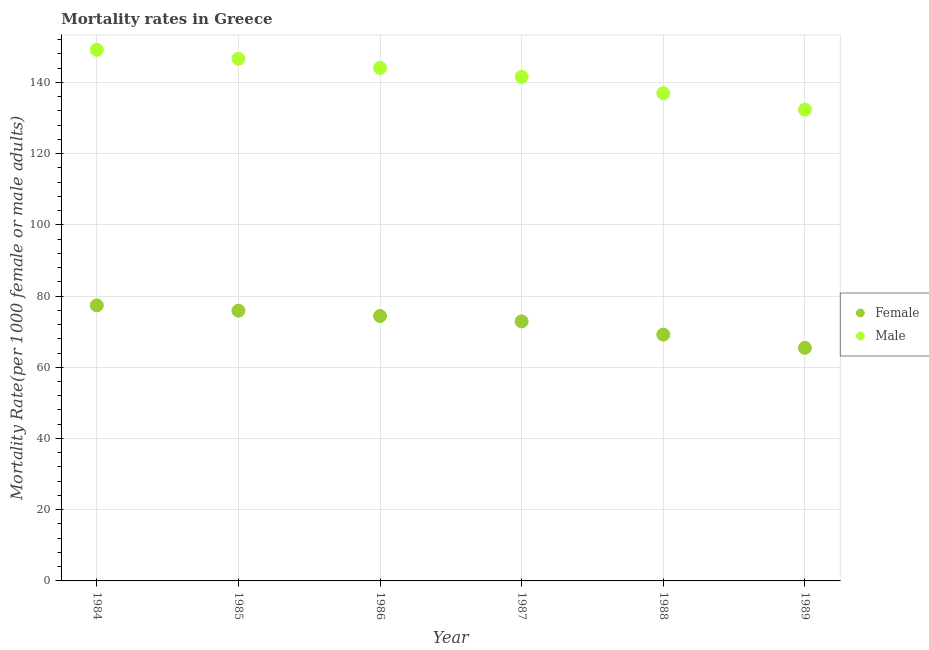Is the number of dotlines equal to the number of legend labels?
Offer a very short reply. Yes. What is the female mortality rate in 1989?
Provide a short and direct response. 65.45. Across all years, what is the maximum male mortality rate?
Ensure brevity in your answer.  149.15. Across all years, what is the minimum male mortality rate?
Make the answer very short. 132.35. In which year was the female mortality rate maximum?
Ensure brevity in your answer.  1984. What is the total male mortality rate in the graph?
Your answer should be very brief. 850.68. What is the difference between the male mortality rate in 1986 and that in 1989?
Offer a very short reply. 11.73. What is the difference between the male mortality rate in 1987 and the female mortality rate in 1984?
Make the answer very short. 64.17. What is the average male mortality rate per year?
Offer a terse response. 141.78. In the year 1988, what is the difference between the male mortality rate and female mortality rate?
Offer a terse response. 67.78. What is the ratio of the male mortality rate in 1986 to that in 1988?
Keep it short and to the point. 1.05. Is the male mortality rate in 1985 less than that in 1988?
Ensure brevity in your answer.  No. What is the difference between the highest and the second highest male mortality rate?
Your answer should be very brief. 2.53. What is the difference between the highest and the lowest female mortality rate?
Offer a very short reply. 11.93. In how many years, is the female mortality rate greater than the average female mortality rate taken over all years?
Offer a terse response. 4. Is the sum of the male mortality rate in 1986 and 1987 greater than the maximum female mortality rate across all years?
Keep it short and to the point. Yes. Is the female mortality rate strictly less than the male mortality rate over the years?
Provide a succinct answer. Yes. How many years are there in the graph?
Give a very brief answer. 6. Where does the legend appear in the graph?
Give a very brief answer. Center right. How are the legend labels stacked?
Give a very brief answer. Vertical. What is the title of the graph?
Keep it short and to the point. Mortality rates in Greece. What is the label or title of the X-axis?
Your response must be concise. Year. What is the label or title of the Y-axis?
Make the answer very short. Mortality Rate(per 1000 female or male adults). What is the Mortality Rate(per 1000 female or male adults) in Female in 1984?
Your answer should be very brief. 77.38. What is the Mortality Rate(per 1000 female or male adults) in Male in 1984?
Make the answer very short. 149.15. What is the Mortality Rate(per 1000 female or male adults) of Female in 1985?
Make the answer very short. 75.88. What is the Mortality Rate(per 1000 female or male adults) of Male in 1985?
Provide a succinct answer. 146.61. What is the Mortality Rate(per 1000 female or male adults) in Female in 1986?
Your answer should be compact. 74.38. What is the Mortality Rate(per 1000 female or male adults) of Male in 1986?
Provide a succinct answer. 144.08. What is the Mortality Rate(per 1000 female or male adults) in Female in 1987?
Offer a very short reply. 72.88. What is the Mortality Rate(per 1000 female or male adults) in Male in 1987?
Your response must be concise. 141.54. What is the Mortality Rate(per 1000 female or male adults) of Female in 1988?
Your response must be concise. 69.17. What is the Mortality Rate(per 1000 female or male adults) in Male in 1988?
Your answer should be compact. 136.95. What is the Mortality Rate(per 1000 female or male adults) of Female in 1989?
Your answer should be compact. 65.45. What is the Mortality Rate(per 1000 female or male adults) in Male in 1989?
Your answer should be very brief. 132.35. Across all years, what is the maximum Mortality Rate(per 1000 female or male adults) of Female?
Ensure brevity in your answer.  77.38. Across all years, what is the maximum Mortality Rate(per 1000 female or male adults) in Male?
Give a very brief answer. 149.15. Across all years, what is the minimum Mortality Rate(per 1000 female or male adults) in Female?
Provide a succinct answer. 65.45. Across all years, what is the minimum Mortality Rate(per 1000 female or male adults) in Male?
Provide a short and direct response. 132.35. What is the total Mortality Rate(per 1000 female or male adults) of Female in the graph?
Make the answer very short. 435.13. What is the total Mortality Rate(per 1000 female or male adults) of Male in the graph?
Offer a terse response. 850.68. What is the difference between the Mortality Rate(per 1000 female or male adults) in Female in 1984 and that in 1985?
Your answer should be compact. 1.5. What is the difference between the Mortality Rate(per 1000 female or male adults) of Male in 1984 and that in 1985?
Your answer should be compact. 2.53. What is the difference between the Mortality Rate(per 1000 female or male adults) of Female in 1984 and that in 1986?
Offer a very short reply. 3. What is the difference between the Mortality Rate(per 1000 female or male adults) in Male in 1984 and that in 1986?
Make the answer very short. 5.07. What is the difference between the Mortality Rate(per 1000 female or male adults) in Female in 1984 and that in 1987?
Provide a succinct answer. 4.5. What is the difference between the Mortality Rate(per 1000 female or male adults) in Male in 1984 and that in 1987?
Provide a succinct answer. 7.6. What is the difference between the Mortality Rate(per 1000 female or male adults) of Female in 1984 and that in 1988?
Your answer should be compact. 8.21. What is the difference between the Mortality Rate(per 1000 female or male adults) in Male in 1984 and that in 1988?
Offer a very short reply. 12.2. What is the difference between the Mortality Rate(per 1000 female or male adults) of Female in 1984 and that in 1989?
Make the answer very short. 11.93. What is the difference between the Mortality Rate(per 1000 female or male adults) of Male in 1984 and that in 1989?
Offer a terse response. 16.8. What is the difference between the Mortality Rate(per 1000 female or male adults) of Female in 1985 and that in 1986?
Provide a succinct answer. 1.5. What is the difference between the Mortality Rate(per 1000 female or male adults) of Male in 1985 and that in 1986?
Keep it short and to the point. 2.53. What is the difference between the Mortality Rate(per 1000 female or male adults) of Female in 1985 and that in 1987?
Give a very brief answer. 3. What is the difference between the Mortality Rate(per 1000 female or male adults) in Male in 1985 and that in 1987?
Provide a succinct answer. 5.07. What is the difference between the Mortality Rate(per 1000 female or male adults) in Female in 1985 and that in 1988?
Provide a short and direct response. 6.71. What is the difference between the Mortality Rate(per 1000 female or male adults) of Male in 1985 and that in 1988?
Your answer should be very brief. 9.67. What is the difference between the Mortality Rate(per 1000 female or male adults) of Female in 1985 and that in 1989?
Offer a terse response. 10.43. What is the difference between the Mortality Rate(per 1000 female or male adults) in Male in 1985 and that in 1989?
Offer a terse response. 14.26. What is the difference between the Mortality Rate(per 1000 female or male adults) of Female in 1986 and that in 1987?
Your response must be concise. 1.5. What is the difference between the Mortality Rate(per 1000 female or male adults) in Male in 1986 and that in 1987?
Your answer should be very brief. 2.53. What is the difference between the Mortality Rate(per 1000 female or male adults) in Female in 1986 and that in 1988?
Keep it short and to the point. 5.21. What is the difference between the Mortality Rate(per 1000 female or male adults) in Male in 1986 and that in 1988?
Your answer should be compact. 7.13. What is the difference between the Mortality Rate(per 1000 female or male adults) of Female in 1986 and that in 1989?
Provide a short and direct response. 8.93. What is the difference between the Mortality Rate(per 1000 female or male adults) in Male in 1986 and that in 1989?
Ensure brevity in your answer.  11.73. What is the difference between the Mortality Rate(per 1000 female or male adults) in Female in 1987 and that in 1988?
Make the answer very short. 3.71. What is the difference between the Mortality Rate(per 1000 female or male adults) of Male in 1987 and that in 1988?
Offer a very short reply. 4.6. What is the difference between the Mortality Rate(per 1000 female or male adults) in Female in 1987 and that in 1989?
Offer a terse response. 7.43. What is the difference between the Mortality Rate(per 1000 female or male adults) in Male in 1987 and that in 1989?
Your response must be concise. 9.19. What is the difference between the Mortality Rate(per 1000 female or male adults) in Female in 1988 and that in 1989?
Provide a short and direct response. 3.71. What is the difference between the Mortality Rate(per 1000 female or male adults) of Male in 1988 and that in 1989?
Provide a short and direct response. 4.6. What is the difference between the Mortality Rate(per 1000 female or male adults) of Female in 1984 and the Mortality Rate(per 1000 female or male adults) of Male in 1985?
Provide a short and direct response. -69.24. What is the difference between the Mortality Rate(per 1000 female or male adults) in Female in 1984 and the Mortality Rate(per 1000 female or male adults) in Male in 1986?
Provide a short and direct response. -66.7. What is the difference between the Mortality Rate(per 1000 female or male adults) in Female in 1984 and the Mortality Rate(per 1000 female or male adults) in Male in 1987?
Your answer should be compact. -64.17. What is the difference between the Mortality Rate(per 1000 female or male adults) in Female in 1984 and the Mortality Rate(per 1000 female or male adults) in Male in 1988?
Your response must be concise. -59.57. What is the difference between the Mortality Rate(per 1000 female or male adults) of Female in 1984 and the Mortality Rate(per 1000 female or male adults) of Male in 1989?
Ensure brevity in your answer.  -54.97. What is the difference between the Mortality Rate(per 1000 female or male adults) of Female in 1985 and the Mortality Rate(per 1000 female or male adults) of Male in 1986?
Give a very brief answer. -68.2. What is the difference between the Mortality Rate(per 1000 female or male adults) in Female in 1985 and the Mortality Rate(per 1000 female or male adults) in Male in 1987?
Make the answer very short. -65.67. What is the difference between the Mortality Rate(per 1000 female or male adults) of Female in 1985 and the Mortality Rate(per 1000 female or male adults) of Male in 1988?
Offer a terse response. -61.07. What is the difference between the Mortality Rate(per 1000 female or male adults) of Female in 1985 and the Mortality Rate(per 1000 female or male adults) of Male in 1989?
Keep it short and to the point. -56.47. What is the difference between the Mortality Rate(per 1000 female or male adults) in Female in 1986 and the Mortality Rate(per 1000 female or male adults) in Male in 1987?
Ensure brevity in your answer.  -67.16. What is the difference between the Mortality Rate(per 1000 female or male adults) of Female in 1986 and the Mortality Rate(per 1000 female or male adults) of Male in 1988?
Your answer should be compact. -62.57. What is the difference between the Mortality Rate(per 1000 female or male adults) in Female in 1986 and the Mortality Rate(per 1000 female or male adults) in Male in 1989?
Your answer should be compact. -57.97. What is the difference between the Mortality Rate(per 1000 female or male adults) of Female in 1987 and the Mortality Rate(per 1000 female or male adults) of Male in 1988?
Provide a short and direct response. -64.07. What is the difference between the Mortality Rate(per 1000 female or male adults) in Female in 1987 and the Mortality Rate(per 1000 female or male adults) in Male in 1989?
Keep it short and to the point. -59.47. What is the difference between the Mortality Rate(per 1000 female or male adults) in Female in 1988 and the Mortality Rate(per 1000 female or male adults) in Male in 1989?
Provide a short and direct response. -63.18. What is the average Mortality Rate(per 1000 female or male adults) of Female per year?
Your answer should be compact. 72.52. What is the average Mortality Rate(per 1000 female or male adults) in Male per year?
Provide a succinct answer. 141.78. In the year 1984, what is the difference between the Mortality Rate(per 1000 female or male adults) of Female and Mortality Rate(per 1000 female or male adults) of Male?
Ensure brevity in your answer.  -71.77. In the year 1985, what is the difference between the Mortality Rate(per 1000 female or male adults) of Female and Mortality Rate(per 1000 female or male adults) of Male?
Provide a succinct answer. -70.74. In the year 1986, what is the difference between the Mortality Rate(per 1000 female or male adults) in Female and Mortality Rate(per 1000 female or male adults) in Male?
Keep it short and to the point. -69.7. In the year 1987, what is the difference between the Mortality Rate(per 1000 female or male adults) of Female and Mortality Rate(per 1000 female or male adults) of Male?
Provide a succinct answer. -68.66. In the year 1988, what is the difference between the Mortality Rate(per 1000 female or male adults) of Female and Mortality Rate(per 1000 female or male adults) of Male?
Your response must be concise. -67.78. In the year 1989, what is the difference between the Mortality Rate(per 1000 female or male adults) in Female and Mortality Rate(per 1000 female or male adults) in Male?
Offer a terse response. -66.9. What is the ratio of the Mortality Rate(per 1000 female or male adults) of Female in 1984 to that in 1985?
Your response must be concise. 1.02. What is the ratio of the Mortality Rate(per 1000 female or male adults) of Male in 1984 to that in 1985?
Make the answer very short. 1.02. What is the ratio of the Mortality Rate(per 1000 female or male adults) in Female in 1984 to that in 1986?
Provide a short and direct response. 1.04. What is the ratio of the Mortality Rate(per 1000 female or male adults) of Male in 1984 to that in 1986?
Make the answer very short. 1.04. What is the ratio of the Mortality Rate(per 1000 female or male adults) in Female in 1984 to that in 1987?
Your answer should be compact. 1.06. What is the ratio of the Mortality Rate(per 1000 female or male adults) of Male in 1984 to that in 1987?
Give a very brief answer. 1.05. What is the ratio of the Mortality Rate(per 1000 female or male adults) in Female in 1984 to that in 1988?
Provide a succinct answer. 1.12. What is the ratio of the Mortality Rate(per 1000 female or male adults) in Male in 1984 to that in 1988?
Provide a succinct answer. 1.09. What is the ratio of the Mortality Rate(per 1000 female or male adults) in Female in 1984 to that in 1989?
Provide a succinct answer. 1.18. What is the ratio of the Mortality Rate(per 1000 female or male adults) in Male in 1984 to that in 1989?
Offer a terse response. 1.13. What is the ratio of the Mortality Rate(per 1000 female or male adults) in Female in 1985 to that in 1986?
Make the answer very short. 1.02. What is the ratio of the Mortality Rate(per 1000 female or male adults) in Male in 1985 to that in 1986?
Ensure brevity in your answer.  1.02. What is the ratio of the Mortality Rate(per 1000 female or male adults) of Female in 1985 to that in 1987?
Offer a very short reply. 1.04. What is the ratio of the Mortality Rate(per 1000 female or male adults) of Male in 1985 to that in 1987?
Ensure brevity in your answer.  1.04. What is the ratio of the Mortality Rate(per 1000 female or male adults) of Female in 1985 to that in 1988?
Offer a very short reply. 1.1. What is the ratio of the Mortality Rate(per 1000 female or male adults) of Male in 1985 to that in 1988?
Your answer should be compact. 1.07. What is the ratio of the Mortality Rate(per 1000 female or male adults) in Female in 1985 to that in 1989?
Ensure brevity in your answer.  1.16. What is the ratio of the Mortality Rate(per 1000 female or male adults) in Male in 1985 to that in 1989?
Your answer should be very brief. 1.11. What is the ratio of the Mortality Rate(per 1000 female or male adults) in Female in 1986 to that in 1987?
Provide a short and direct response. 1.02. What is the ratio of the Mortality Rate(per 1000 female or male adults) in Male in 1986 to that in 1987?
Make the answer very short. 1.02. What is the ratio of the Mortality Rate(per 1000 female or male adults) of Female in 1986 to that in 1988?
Your answer should be compact. 1.08. What is the ratio of the Mortality Rate(per 1000 female or male adults) in Male in 1986 to that in 1988?
Your answer should be compact. 1.05. What is the ratio of the Mortality Rate(per 1000 female or male adults) of Female in 1986 to that in 1989?
Your response must be concise. 1.14. What is the ratio of the Mortality Rate(per 1000 female or male adults) of Male in 1986 to that in 1989?
Your answer should be compact. 1.09. What is the ratio of the Mortality Rate(per 1000 female or male adults) in Female in 1987 to that in 1988?
Give a very brief answer. 1.05. What is the ratio of the Mortality Rate(per 1000 female or male adults) of Male in 1987 to that in 1988?
Keep it short and to the point. 1.03. What is the ratio of the Mortality Rate(per 1000 female or male adults) of Female in 1987 to that in 1989?
Your response must be concise. 1.11. What is the ratio of the Mortality Rate(per 1000 female or male adults) in Male in 1987 to that in 1989?
Make the answer very short. 1.07. What is the ratio of the Mortality Rate(per 1000 female or male adults) in Female in 1988 to that in 1989?
Your response must be concise. 1.06. What is the ratio of the Mortality Rate(per 1000 female or male adults) of Male in 1988 to that in 1989?
Give a very brief answer. 1.03. What is the difference between the highest and the second highest Mortality Rate(per 1000 female or male adults) in Female?
Offer a very short reply. 1.5. What is the difference between the highest and the second highest Mortality Rate(per 1000 female or male adults) of Male?
Provide a succinct answer. 2.53. What is the difference between the highest and the lowest Mortality Rate(per 1000 female or male adults) in Female?
Your answer should be compact. 11.93. What is the difference between the highest and the lowest Mortality Rate(per 1000 female or male adults) in Male?
Offer a terse response. 16.8. 